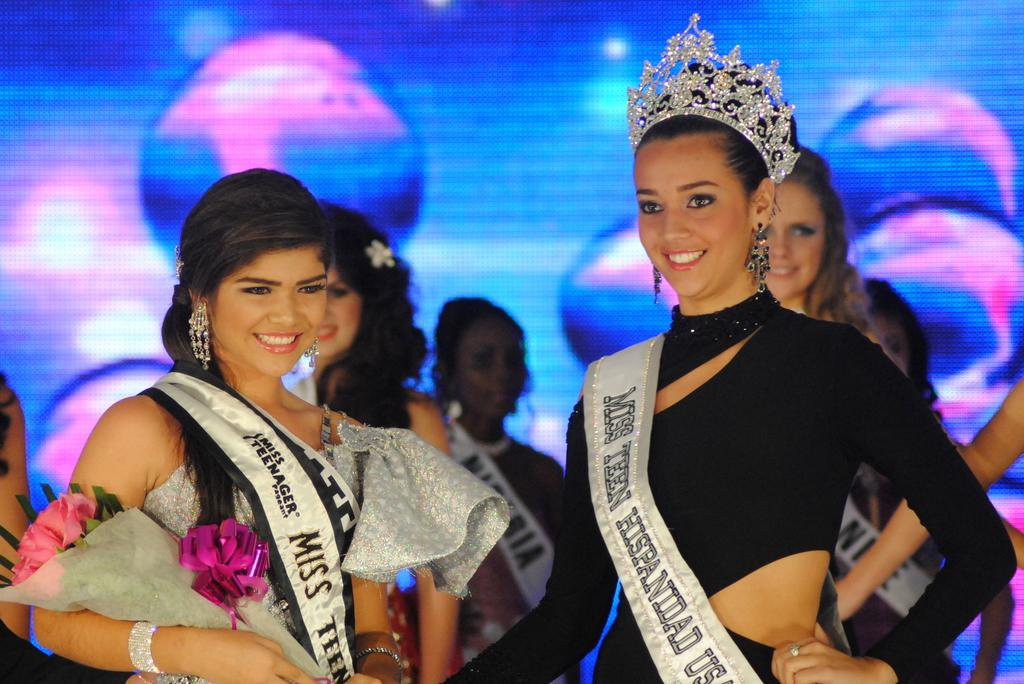<image>
Describe the image concisely. the word Miss on one of the show contestants 